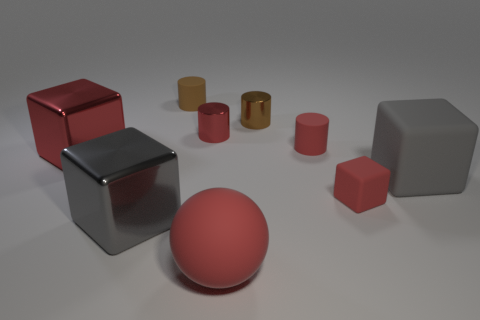Subtract all big cubes. How many cubes are left? 1 Subtract 1 cylinders. How many cylinders are left? 3 Subtract all brown cylinders. How many cylinders are left? 2 Subtract all cyan cylinders. How many cyan balls are left? 0 Subtract all small green blocks. Subtract all gray rubber things. How many objects are left? 8 Add 9 matte balls. How many matte balls are left? 10 Add 8 brown cylinders. How many brown cylinders exist? 10 Subtract 0 green balls. How many objects are left? 9 Subtract all cubes. How many objects are left? 5 Subtract all gray spheres. Subtract all gray cylinders. How many spheres are left? 1 